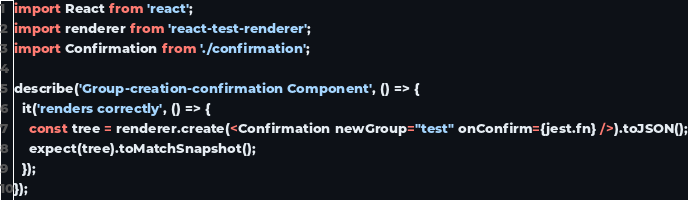Convert code to text. <code><loc_0><loc_0><loc_500><loc_500><_JavaScript_>import React from 'react';
import renderer from 'react-test-renderer';
import Confirmation from './confirmation';

describe('Group-creation-confirmation Component', () => {
  it('renders correctly', () => {
    const tree = renderer.create(<Confirmation newGroup="test" onConfirm={jest.fn} />).toJSON();
    expect(tree).toMatchSnapshot();
  });
});
</code> 